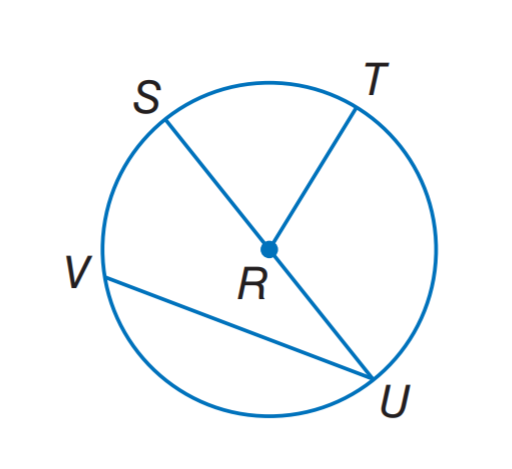Question: In \odot R. If S U = 16.2, what is R T?
Choices:
A. 8.1
B. 16.2
C. 24.3
D. 32.4
Answer with the letter. Answer: A 